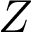<formula> <loc_0><loc_0><loc_500><loc_500>Z</formula> 